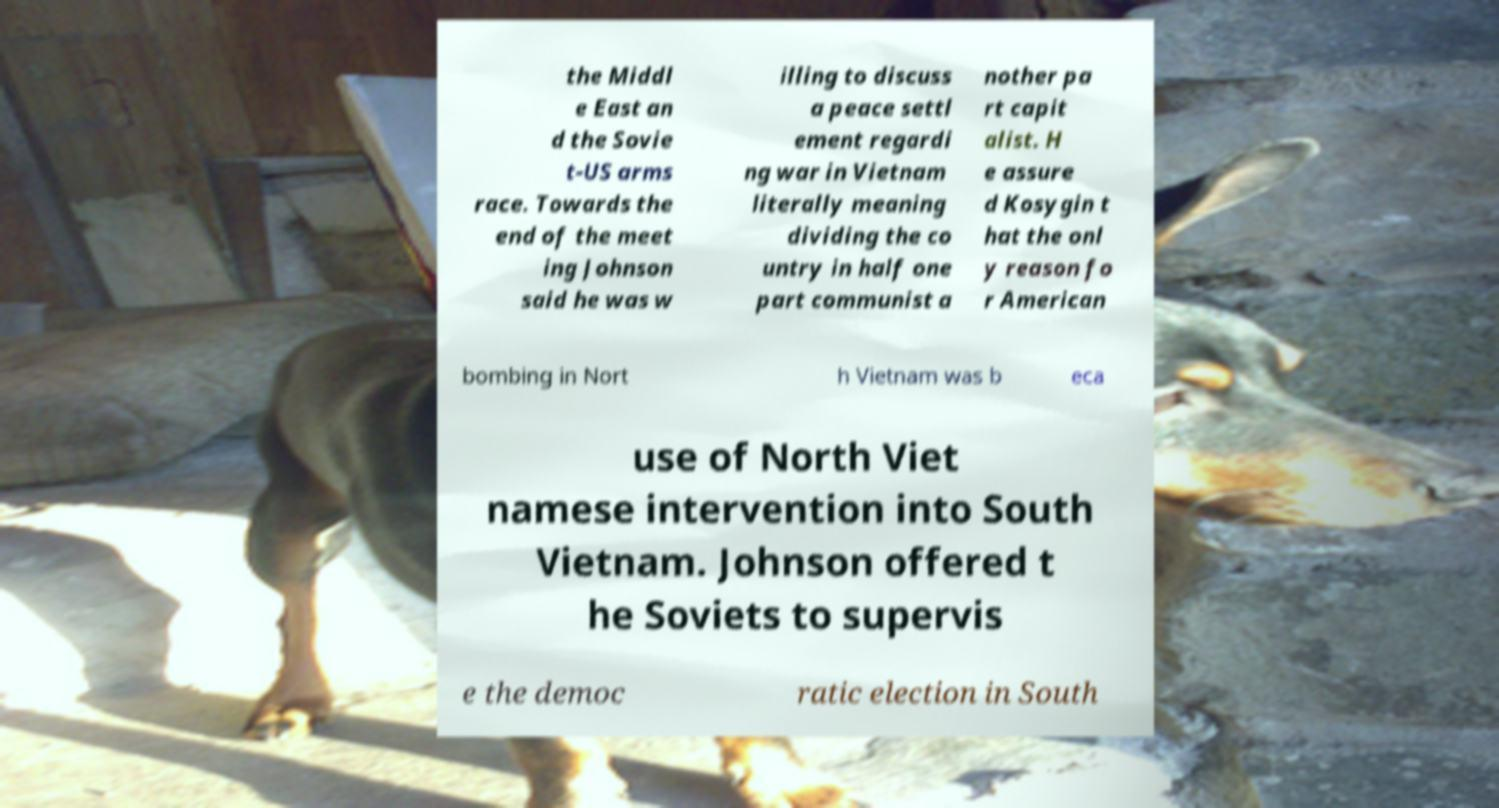Can you read and provide the text displayed in the image?This photo seems to have some interesting text. Can you extract and type it out for me? the Middl e East an d the Sovie t-US arms race. Towards the end of the meet ing Johnson said he was w illing to discuss a peace settl ement regardi ng war in Vietnam literally meaning dividing the co untry in half one part communist a nother pa rt capit alist. H e assure d Kosygin t hat the onl y reason fo r American bombing in Nort h Vietnam was b eca use of North Viet namese intervention into South Vietnam. Johnson offered t he Soviets to supervis e the democ ratic election in South 